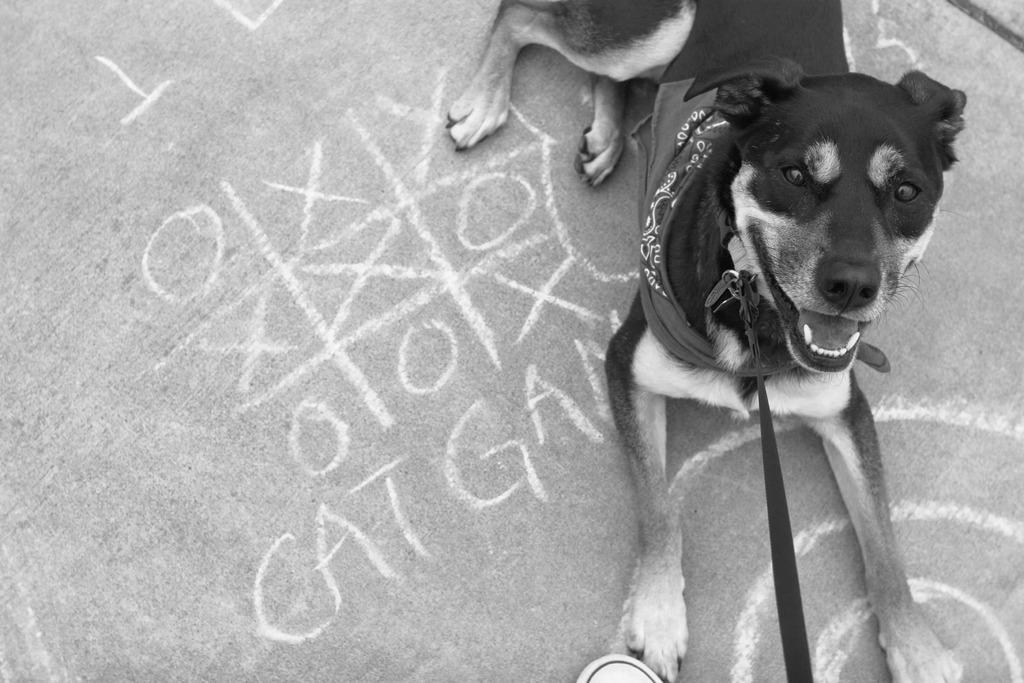Can you describe this image briefly? In this picture we can observe a dog sitting on the floor. We can observe a belt around its neck. There is some text on the floor. This is a black and white image. 